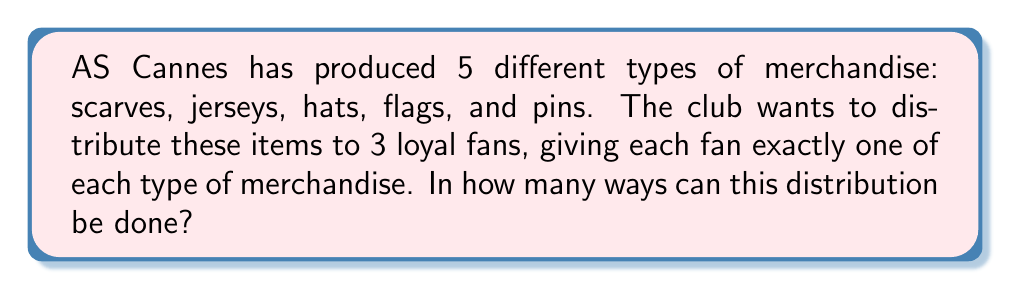Can you answer this question? Let's approach this step-by-step:

1) We need to distribute 5 different types of items to 3 fans.

2) For each type of merchandise:
   - The first fan can be given any of the 3 items
   - The second fan can be given either of the 2 remaining items
   - The last fan must receive the last remaining item

3) This means for each type of merchandise, we have 3 x 2 x 1 = 6 ways to distribute it.

4) Since we have 5 different types of merchandise, and the distribution of each type is independent of the others, we can use the multiplication principle.

5) The total number of ways to distribute all 5 types of merchandise is:

   $$ 6 \times 6 \times 6 \times 6 \times 6 = 6^5 $$

6) Calculating this:

   $$ 6^5 = 7,776 $$

Therefore, there are 7,776 ways to distribute the AS Cannes merchandise among the 3 loyal fans.
Answer: $7,776$ 